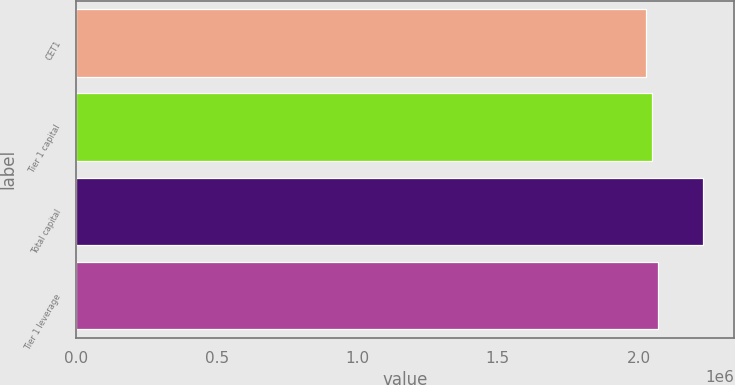Convert chart to OTSL. <chart><loc_0><loc_0><loc_500><loc_500><bar_chart><fcel>CET1<fcel>Tier 1 capital<fcel>Total capital<fcel>Tier 1 leverage<nl><fcel>2.02852e+06<fcel>2.04857e+06<fcel>2.22899e+06<fcel>2.06862e+06<nl></chart> 